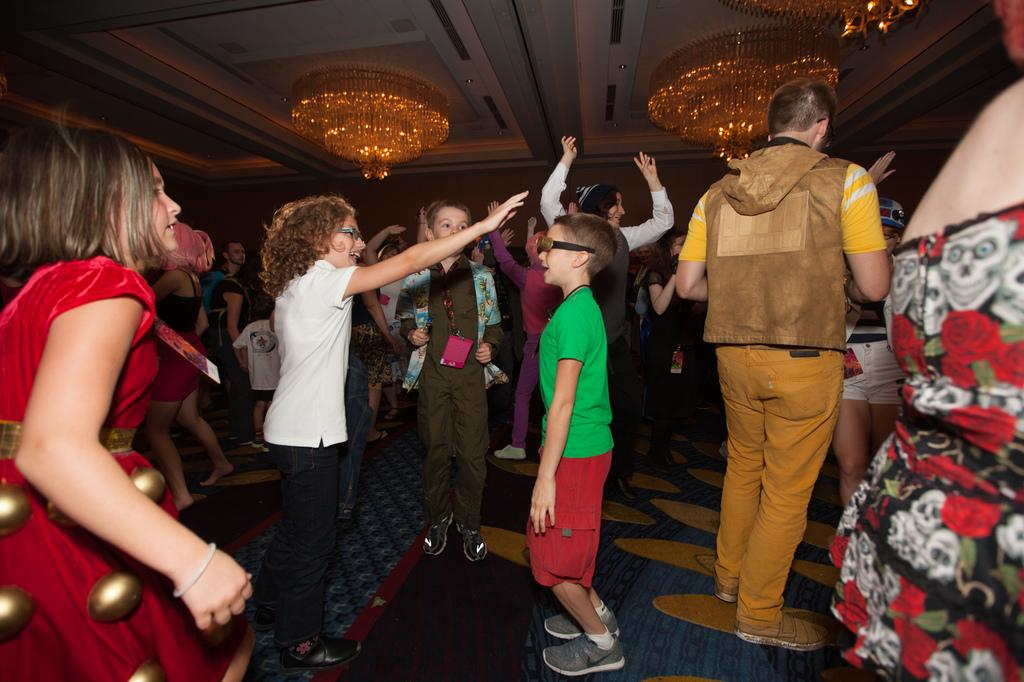What is the main subject of the image? The main subject of the image is a group of people. What are the people in the image doing? The people are standing. What can be seen at the top of the image? There is a roof visible at the top of the image. Can you tell me how many lakes are visible in the image? There are no lakes visible in the image; it features a group of people standing and a roof. What type of burst can be seen happening in the image? There is no burst present in the image. 